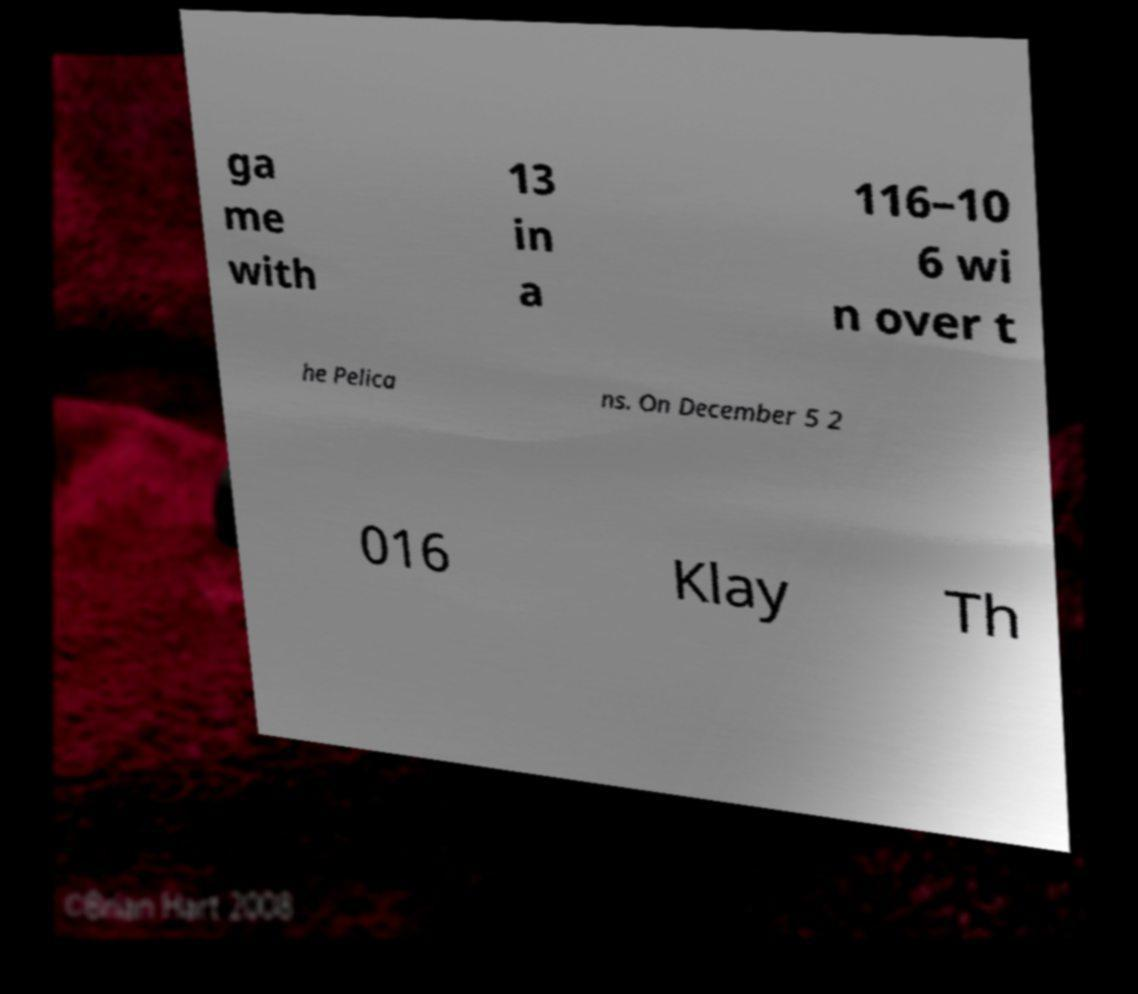Can you read and provide the text displayed in the image?This photo seems to have some interesting text. Can you extract and type it out for me? ga me with 13 in a 116–10 6 wi n over t he Pelica ns. On December 5 2 016 Klay Th 